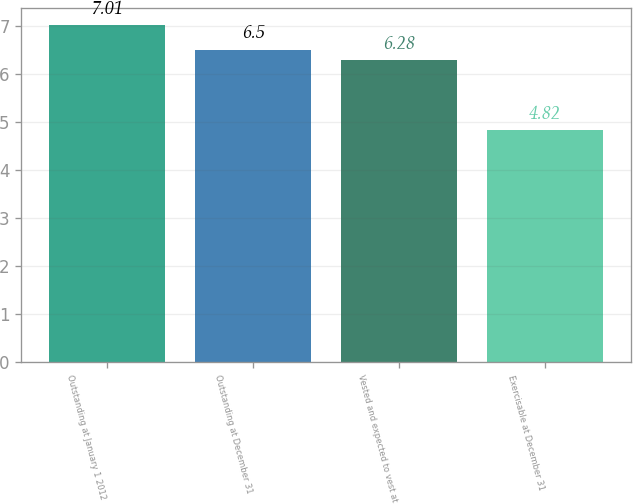Convert chart to OTSL. <chart><loc_0><loc_0><loc_500><loc_500><bar_chart><fcel>Outstanding at January 1 2012<fcel>Outstanding at December 31<fcel>Vested and expected to vest at<fcel>Exercisable at December 31<nl><fcel>7.01<fcel>6.5<fcel>6.28<fcel>4.82<nl></chart> 